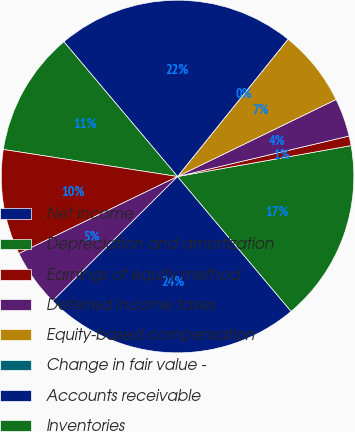Convert chart. <chart><loc_0><loc_0><loc_500><loc_500><pie_chart><fcel>Net income<fcel>Depreciation and amortization<fcel>Earnings of equity method<fcel>Deferred income taxes<fcel>Equity-based compensation<fcel>Change in fair value -<fcel>Accounts receivable<fcel>Inventories<fcel>Income taxes receivable<fcel>Prepayments and other<nl><fcel>23.68%<fcel>16.67%<fcel>0.88%<fcel>3.51%<fcel>7.02%<fcel>0.0%<fcel>21.93%<fcel>11.4%<fcel>9.65%<fcel>5.26%<nl></chart> 